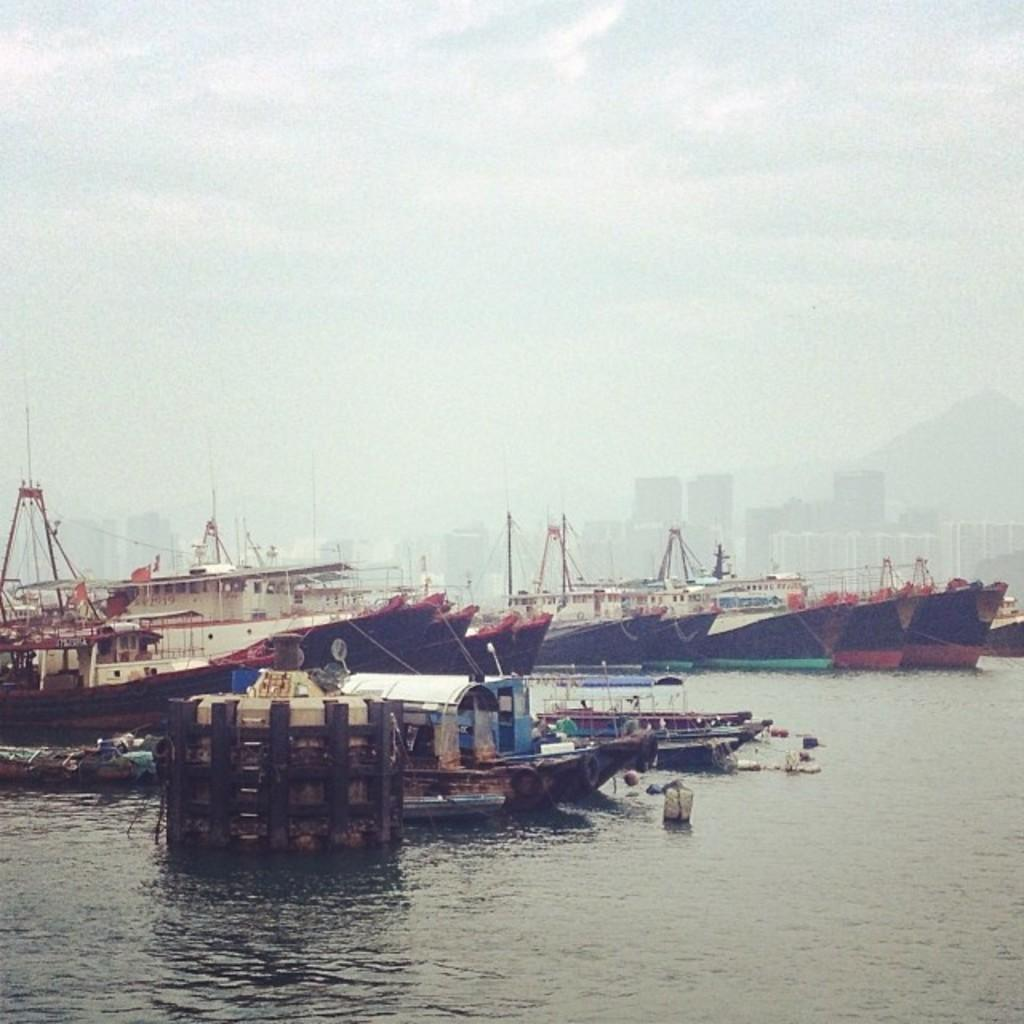What is on the water in the image? There are boats and other objects on the water in the image. What can be seen in the background of the image? There are buildings, mountains, and the sky visible in the background of the image. Where is the parcel being delivered in the image? There is no parcel present in the image. How much money is being exchanged in the image? There is no money being exchanged in the image. 